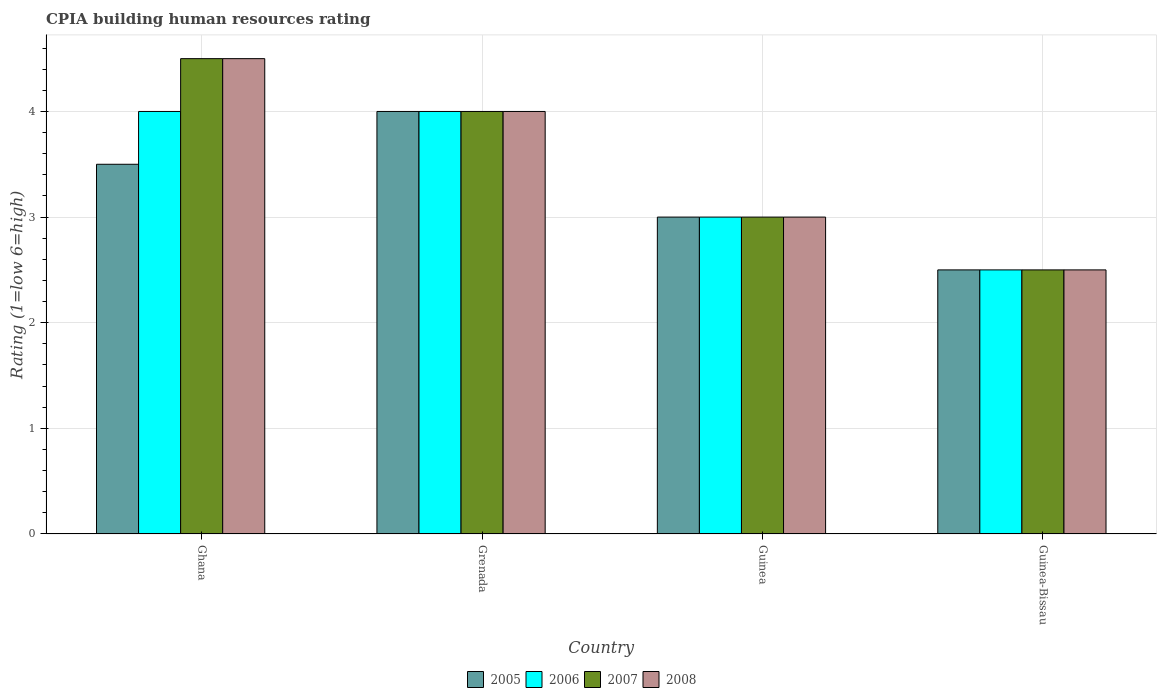Are the number of bars on each tick of the X-axis equal?
Your answer should be very brief. Yes. How many bars are there on the 2nd tick from the left?
Your answer should be very brief. 4. How many bars are there on the 3rd tick from the right?
Provide a short and direct response. 4. What is the label of the 1st group of bars from the left?
Give a very brief answer. Ghana. Across all countries, what is the maximum CPIA rating in 2006?
Make the answer very short. 4. In which country was the CPIA rating in 2006 maximum?
Your answer should be compact. Ghana. In which country was the CPIA rating in 2008 minimum?
Offer a very short reply. Guinea-Bissau. What is the total CPIA rating in 2006 in the graph?
Keep it short and to the point. 13.5. What is the difference between the CPIA rating in 2007 in Ghana and that in Guinea-Bissau?
Give a very brief answer. 2. What is the difference between the CPIA rating in 2006 in Grenada and the CPIA rating in 2005 in Guinea-Bissau?
Keep it short and to the point. 1.5. In how many countries, is the CPIA rating in 2008 greater than 0.4?
Give a very brief answer. 4. What is the ratio of the CPIA rating in 2006 in Grenada to that in Guinea?
Offer a terse response. 1.33. Is the CPIA rating in 2005 in Grenada less than that in Guinea-Bissau?
Keep it short and to the point. No. Is the difference between the CPIA rating in 2005 in Guinea and Guinea-Bissau greater than the difference between the CPIA rating in 2007 in Guinea and Guinea-Bissau?
Offer a terse response. No. What is the difference between the highest and the lowest CPIA rating in 2005?
Provide a succinct answer. 1.5. In how many countries, is the CPIA rating in 2005 greater than the average CPIA rating in 2005 taken over all countries?
Make the answer very short. 2. What does the 4th bar from the left in Grenada represents?
Give a very brief answer. 2008. Is it the case that in every country, the sum of the CPIA rating in 2008 and CPIA rating in 2006 is greater than the CPIA rating in 2005?
Provide a succinct answer. Yes. What is the difference between two consecutive major ticks on the Y-axis?
Make the answer very short. 1. Are the values on the major ticks of Y-axis written in scientific E-notation?
Offer a very short reply. No. Does the graph contain grids?
Offer a terse response. Yes. Where does the legend appear in the graph?
Offer a very short reply. Bottom center. How are the legend labels stacked?
Offer a terse response. Horizontal. What is the title of the graph?
Your answer should be compact. CPIA building human resources rating. What is the label or title of the X-axis?
Ensure brevity in your answer.  Country. What is the label or title of the Y-axis?
Your answer should be very brief. Rating (1=low 6=high). What is the Rating (1=low 6=high) of 2005 in Ghana?
Provide a short and direct response. 3.5. What is the Rating (1=low 6=high) in 2006 in Ghana?
Your answer should be very brief. 4. What is the Rating (1=low 6=high) in 2008 in Ghana?
Offer a very short reply. 4.5. What is the Rating (1=low 6=high) of 2005 in Grenada?
Your response must be concise. 4. What is the Rating (1=low 6=high) of 2006 in Grenada?
Keep it short and to the point. 4. What is the Rating (1=low 6=high) of 2007 in Grenada?
Ensure brevity in your answer.  4. What is the Rating (1=low 6=high) in 2008 in Grenada?
Offer a very short reply. 4. What is the Rating (1=low 6=high) of 2005 in Guinea?
Offer a terse response. 3. What is the Rating (1=low 6=high) in 2006 in Guinea?
Offer a terse response. 3. What is the Rating (1=low 6=high) in 2008 in Guinea?
Your response must be concise. 3. What is the Rating (1=low 6=high) of 2005 in Guinea-Bissau?
Your answer should be very brief. 2.5. Across all countries, what is the maximum Rating (1=low 6=high) of 2006?
Keep it short and to the point. 4. Across all countries, what is the minimum Rating (1=low 6=high) of 2005?
Provide a succinct answer. 2.5. Across all countries, what is the minimum Rating (1=low 6=high) of 2006?
Keep it short and to the point. 2.5. Across all countries, what is the minimum Rating (1=low 6=high) of 2007?
Your response must be concise. 2.5. What is the total Rating (1=low 6=high) in 2006 in the graph?
Provide a short and direct response. 13.5. What is the total Rating (1=low 6=high) of 2007 in the graph?
Give a very brief answer. 14. What is the total Rating (1=low 6=high) in 2008 in the graph?
Make the answer very short. 14. What is the difference between the Rating (1=low 6=high) of 2005 in Ghana and that in Grenada?
Make the answer very short. -0.5. What is the difference between the Rating (1=low 6=high) of 2006 in Ghana and that in Grenada?
Make the answer very short. 0. What is the difference between the Rating (1=low 6=high) in 2008 in Ghana and that in Grenada?
Offer a very short reply. 0.5. What is the difference between the Rating (1=low 6=high) of 2005 in Ghana and that in Guinea?
Offer a terse response. 0.5. What is the difference between the Rating (1=low 6=high) in 2005 in Ghana and that in Guinea-Bissau?
Provide a succinct answer. 1. What is the difference between the Rating (1=low 6=high) of 2006 in Ghana and that in Guinea-Bissau?
Provide a short and direct response. 1.5. What is the difference between the Rating (1=low 6=high) in 2007 in Ghana and that in Guinea-Bissau?
Ensure brevity in your answer.  2. What is the difference between the Rating (1=low 6=high) in 2006 in Grenada and that in Guinea?
Your answer should be compact. 1. What is the difference between the Rating (1=low 6=high) of 2005 in Grenada and that in Guinea-Bissau?
Provide a succinct answer. 1.5. What is the difference between the Rating (1=low 6=high) of 2006 in Grenada and that in Guinea-Bissau?
Make the answer very short. 1.5. What is the difference between the Rating (1=low 6=high) in 2005 in Guinea and that in Guinea-Bissau?
Provide a short and direct response. 0.5. What is the difference between the Rating (1=low 6=high) of 2007 in Guinea and that in Guinea-Bissau?
Give a very brief answer. 0.5. What is the difference between the Rating (1=low 6=high) of 2005 in Ghana and the Rating (1=low 6=high) of 2006 in Guinea?
Provide a short and direct response. 0.5. What is the difference between the Rating (1=low 6=high) of 2005 in Ghana and the Rating (1=low 6=high) of 2007 in Guinea?
Provide a short and direct response. 0.5. What is the difference between the Rating (1=low 6=high) in 2006 in Ghana and the Rating (1=low 6=high) in 2007 in Guinea?
Provide a short and direct response. 1. What is the difference between the Rating (1=low 6=high) of 2005 in Ghana and the Rating (1=low 6=high) of 2007 in Guinea-Bissau?
Your answer should be very brief. 1. What is the difference between the Rating (1=low 6=high) of 2005 in Ghana and the Rating (1=low 6=high) of 2008 in Guinea-Bissau?
Provide a succinct answer. 1. What is the difference between the Rating (1=low 6=high) of 2006 in Ghana and the Rating (1=low 6=high) of 2007 in Guinea-Bissau?
Your answer should be very brief. 1.5. What is the difference between the Rating (1=low 6=high) in 2007 in Ghana and the Rating (1=low 6=high) in 2008 in Guinea-Bissau?
Offer a terse response. 2. What is the difference between the Rating (1=low 6=high) of 2005 in Grenada and the Rating (1=low 6=high) of 2008 in Guinea?
Keep it short and to the point. 1. What is the difference between the Rating (1=low 6=high) of 2006 in Grenada and the Rating (1=low 6=high) of 2007 in Guinea?
Your answer should be compact. 1. What is the difference between the Rating (1=low 6=high) of 2007 in Grenada and the Rating (1=low 6=high) of 2008 in Guinea?
Offer a very short reply. 1. What is the difference between the Rating (1=low 6=high) in 2005 in Grenada and the Rating (1=low 6=high) in 2006 in Guinea-Bissau?
Your answer should be compact. 1.5. What is the difference between the Rating (1=low 6=high) of 2005 in Grenada and the Rating (1=low 6=high) of 2007 in Guinea-Bissau?
Your response must be concise. 1.5. What is the difference between the Rating (1=low 6=high) of 2005 in Grenada and the Rating (1=low 6=high) of 2008 in Guinea-Bissau?
Your answer should be very brief. 1.5. What is the difference between the Rating (1=low 6=high) of 2006 in Grenada and the Rating (1=low 6=high) of 2007 in Guinea-Bissau?
Your response must be concise. 1.5. What is the difference between the Rating (1=low 6=high) of 2007 in Grenada and the Rating (1=low 6=high) of 2008 in Guinea-Bissau?
Your response must be concise. 1.5. What is the difference between the Rating (1=low 6=high) in 2005 in Guinea and the Rating (1=low 6=high) in 2006 in Guinea-Bissau?
Your answer should be compact. 0.5. What is the difference between the Rating (1=low 6=high) in 2005 in Guinea and the Rating (1=low 6=high) in 2008 in Guinea-Bissau?
Give a very brief answer. 0.5. What is the difference between the Rating (1=low 6=high) in 2006 in Guinea and the Rating (1=low 6=high) in 2007 in Guinea-Bissau?
Ensure brevity in your answer.  0.5. What is the difference between the Rating (1=low 6=high) of 2006 in Guinea and the Rating (1=low 6=high) of 2008 in Guinea-Bissau?
Make the answer very short. 0.5. What is the difference between the Rating (1=low 6=high) of 2007 in Guinea and the Rating (1=low 6=high) of 2008 in Guinea-Bissau?
Offer a very short reply. 0.5. What is the average Rating (1=low 6=high) of 2006 per country?
Make the answer very short. 3.38. What is the average Rating (1=low 6=high) of 2007 per country?
Provide a short and direct response. 3.5. What is the difference between the Rating (1=low 6=high) in 2005 and Rating (1=low 6=high) in 2006 in Ghana?
Keep it short and to the point. -0.5. What is the difference between the Rating (1=low 6=high) in 2005 and Rating (1=low 6=high) in 2007 in Ghana?
Offer a terse response. -1. What is the difference between the Rating (1=low 6=high) of 2006 and Rating (1=low 6=high) of 2007 in Ghana?
Provide a short and direct response. -0.5. What is the difference between the Rating (1=low 6=high) of 2006 and Rating (1=low 6=high) of 2008 in Ghana?
Your answer should be very brief. -0.5. What is the difference between the Rating (1=low 6=high) of 2005 and Rating (1=low 6=high) of 2008 in Grenada?
Offer a very short reply. 0. What is the difference between the Rating (1=low 6=high) of 2006 and Rating (1=low 6=high) of 2008 in Grenada?
Your answer should be compact. 0. What is the difference between the Rating (1=low 6=high) in 2005 and Rating (1=low 6=high) in 2006 in Guinea?
Give a very brief answer. 0. What is the difference between the Rating (1=low 6=high) in 2006 and Rating (1=low 6=high) in 2007 in Guinea?
Offer a very short reply. 0. What is the difference between the Rating (1=low 6=high) in 2005 and Rating (1=low 6=high) in 2008 in Guinea-Bissau?
Your answer should be compact. 0. What is the difference between the Rating (1=low 6=high) of 2006 and Rating (1=low 6=high) of 2007 in Guinea-Bissau?
Your answer should be very brief. 0. What is the difference between the Rating (1=low 6=high) of 2007 and Rating (1=low 6=high) of 2008 in Guinea-Bissau?
Keep it short and to the point. 0. What is the ratio of the Rating (1=low 6=high) of 2005 in Ghana to that in Grenada?
Give a very brief answer. 0.88. What is the ratio of the Rating (1=low 6=high) in 2005 in Ghana to that in Guinea?
Your response must be concise. 1.17. What is the ratio of the Rating (1=low 6=high) of 2007 in Ghana to that in Guinea?
Make the answer very short. 1.5. What is the ratio of the Rating (1=low 6=high) in 2008 in Ghana to that in Guinea?
Ensure brevity in your answer.  1.5. What is the ratio of the Rating (1=low 6=high) of 2007 in Ghana to that in Guinea-Bissau?
Make the answer very short. 1.8. What is the ratio of the Rating (1=low 6=high) of 2007 in Grenada to that in Guinea?
Offer a terse response. 1.33. What is the ratio of the Rating (1=low 6=high) in 2008 in Grenada to that in Guinea?
Make the answer very short. 1.33. What is the ratio of the Rating (1=low 6=high) in 2005 in Grenada to that in Guinea-Bissau?
Provide a succinct answer. 1.6. What is the ratio of the Rating (1=low 6=high) of 2007 in Grenada to that in Guinea-Bissau?
Your answer should be compact. 1.6. What is the ratio of the Rating (1=low 6=high) of 2006 in Guinea to that in Guinea-Bissau?
Ensure brevity in your answer.  1.2. What is the ratio of the Rating (1=low 6=high) in 2007 in Guinea to that in Guinea-Bissau?
Keep it short and to the point. 1.2. What is the ratio of the Rating (1=low 6=high) in 2008 in Guinea to that in Guinea-Bissau?
Your response must be concise. 1.2. What is the difference between the highest and the second highest Rating (1=low 6=high) in 2005?
Provide a short and direct response. 0.5. What is the difference between the highest and the second highest Rating (1=low 6=high) of 2006?
Provide a succinct answer. 0. What is the difference between the highest and the second highest Rating (1=low 6=high) in 2008?
Your answer should be compact. 0.5. What is the difference between the highest and the lowest Rating (1=low 6=high) of 2006?
Offer a terse response. 1.5. What is the difference between the highest and the lowest Rating (1=low 6=high) in 2007?
Provide a short and direct response. 2. What is the difference between the highest and the lowest Rating (1=low 6=high) in 2008?
Provide a short and direct response. 2. 